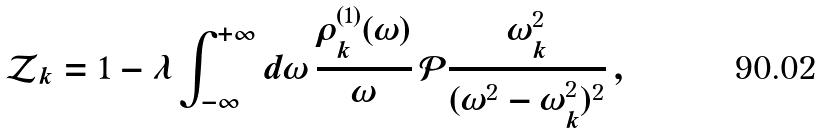<formula> <loc_0><loc_0><loc_500><loc_500>\mathcal { Z } _ { k } = 1 - \lambda \int _ { - \infty } ^ { + \infty } d \omega \, \frac { \rho ^ { ( 1 ) } _ { k } ( \omega ) } { \omega } \, \mathcal { P } \frac { \omega ^ { 2 } _ { k } } { ( \omega ^ { 2 } - \omega ^ { 2 } _ { k } ) ^ { 2 } } \, ,</formula> 